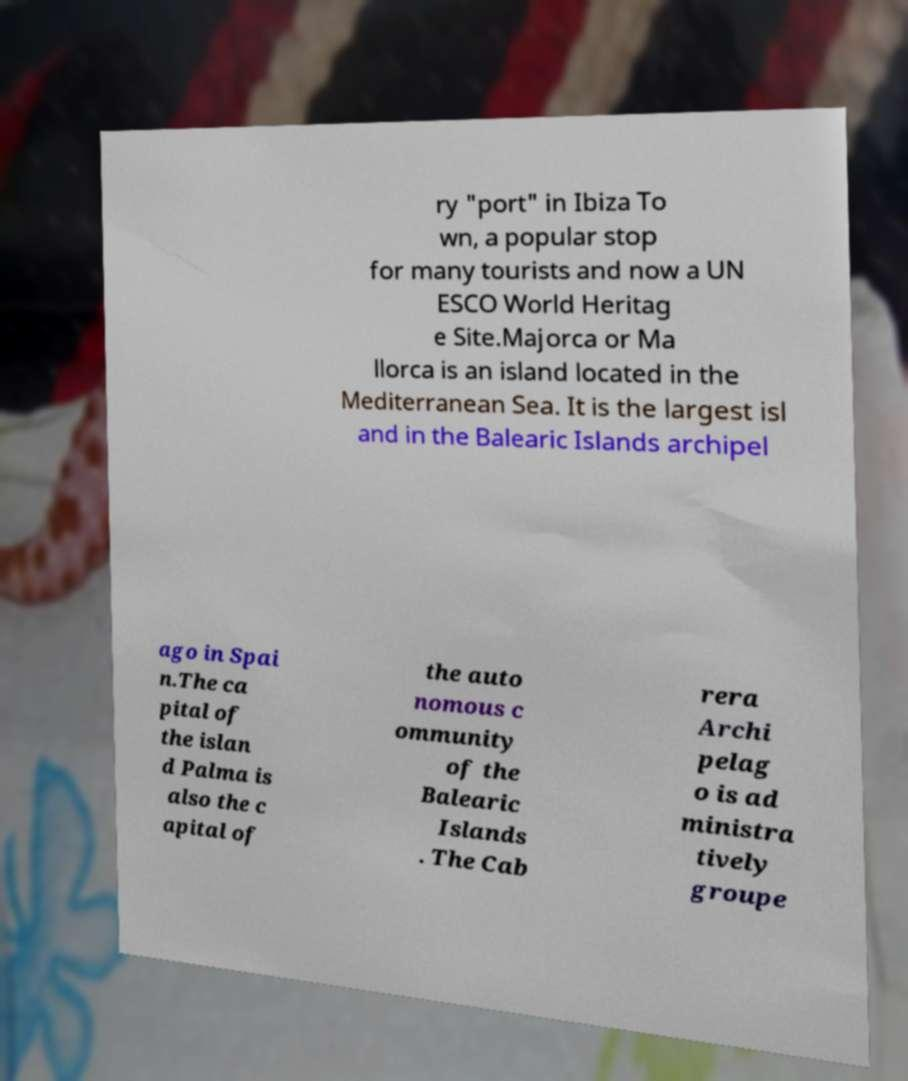For documentation purposes, I need the text within this image transcribed. Could you provide that? ry "port" in Ibiza To wn, a popular stop for many tourists and now a UN ESCO World Heritag e Site.Majorca or Ma llorca is an island located in the Mediterranean Sea. It is the largest isl and in the Balearic Islands archipel ago in Spai n.The ca pital of the islan d Palma is also the c apital of the auto nomous c ommunity of the Balearic Islands . The Cab rera Archi pelag o is ad ministra tively groupe 